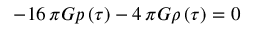<formula> <loc_0><loc_0><loc_500><loc_500>- 1 6 \, \pi G p \left ( { \tau } \right ) - 4 \, \pi G \rho \left ( { \tau } \right ) = 0</formula> 